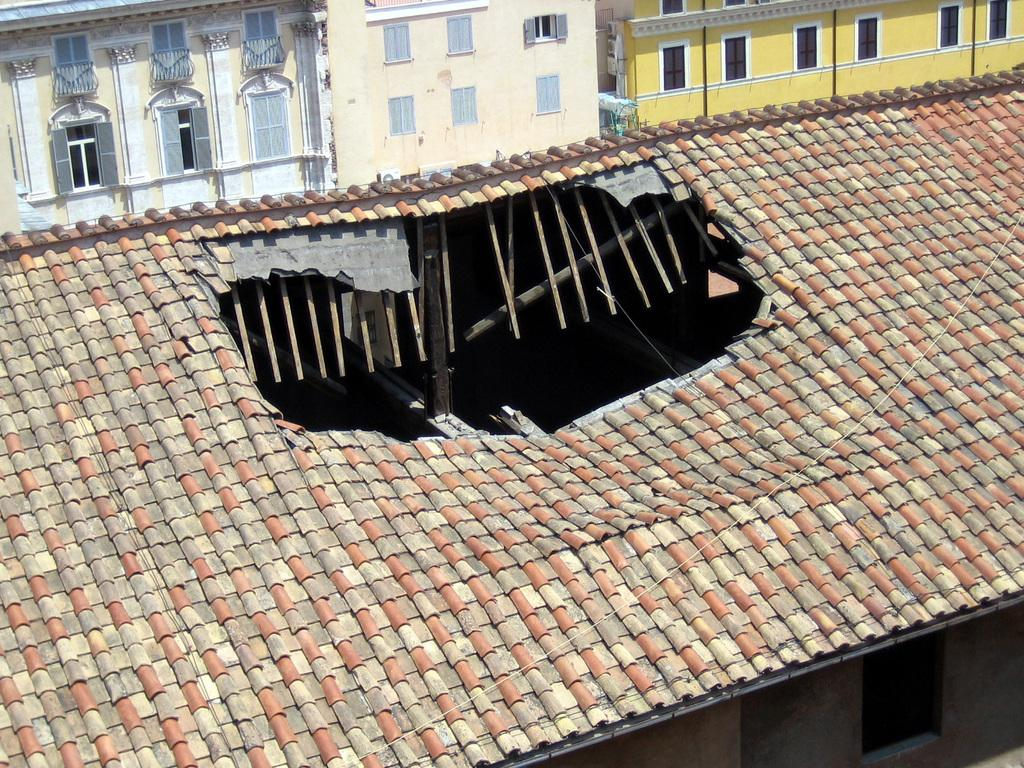What type of structure is in the image? There is a house in the image. Can you describe the condition of the house's roof? The house has a broken roof. What else can be seen in the background of the image? There are other houses visible in the background of the image. What feature do the houses in the background have? The houses in the background have windows. Where are the toys located in the image? There are no toys present in the image. What type of plane can be seen flying over the houses in the image? There is no plane visible in the image. 